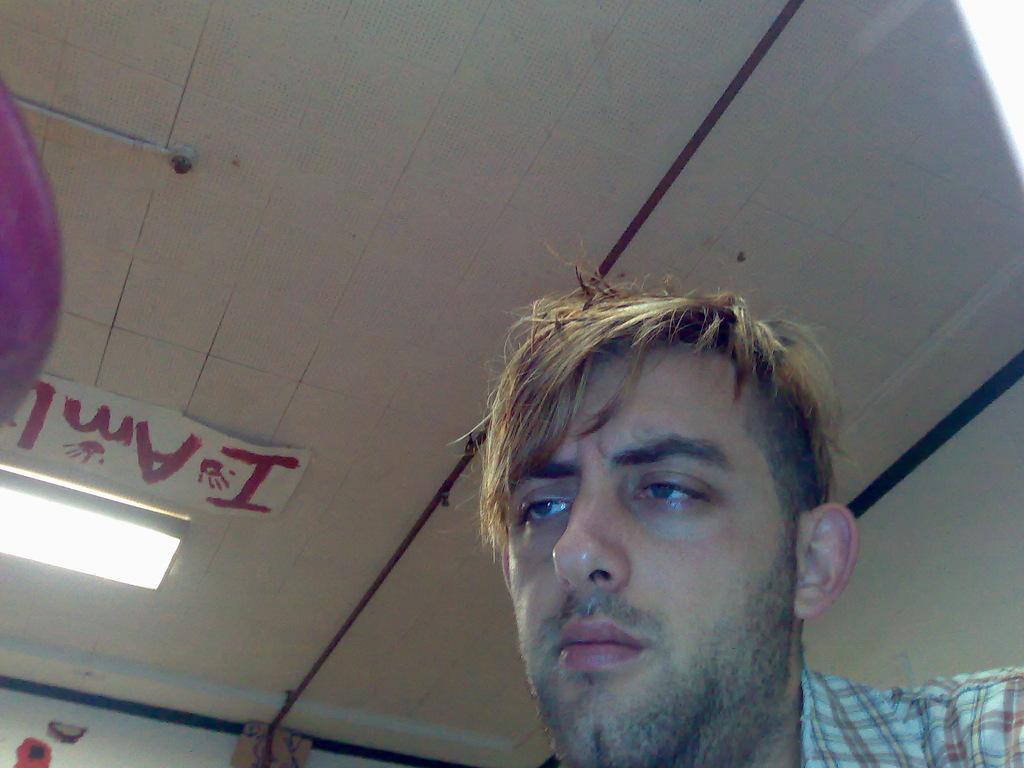How would you summarize this image in a sentence or two? In this image I can see the person and the person is wearing white and brown color shirt. In the background I can see the light and the wall is in white color. 